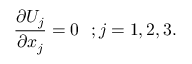<formula> <loc_0><loc_0><loc_500><loc_500>{ \frac { \partial U _ { j } } { \partial x _ { j } } } = 0 ; j = 1 , 2 , 3 .</formula> 